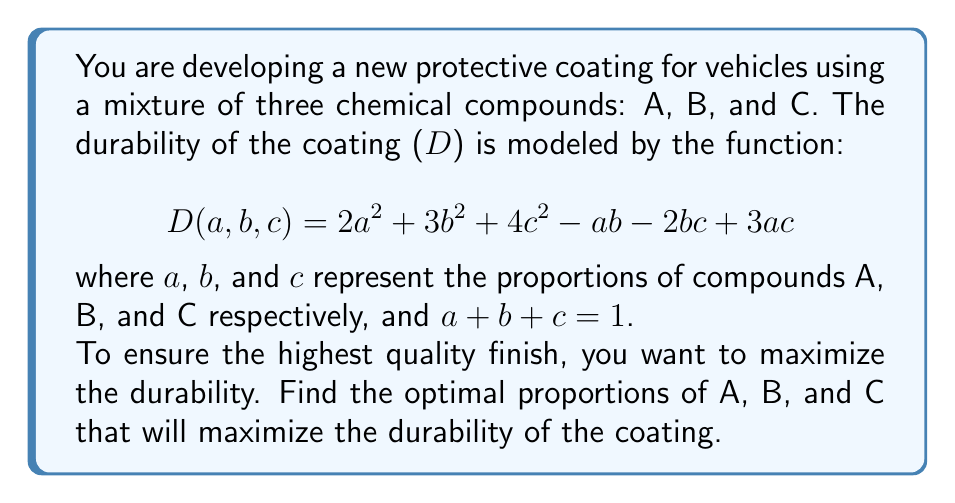Show me your answer to this math problem. To find the maximum durability, we need to optimize the function D(a,b,c) subject to the constraint a + b + c = 1. We can use the method of Lagrange multipliers:

1) Define the Lagrangian function:
   $$ L(a,b,c,λ) = 2a^2 + 3b^2 + 4c^2 - ab - 2bc + 3ac + λ(a + b + c - 1) $$

2) Calculate partial derivatives and set them to zero:
   $$ \frac{\partial L}{\partial a} = 4a - b + 3c + λ = 0 $$
   $$ \frac{\partial L}{\partial b} = 6b - a - 2c + λ = 0 $$
   $$ \frac{\partial L}{\partial c} = 8c - 2b + 3a + λ = 0 $$
   $$ \frac{\partial L}{\partial λ} = a + b + c - 1 = 0 $$

3) Solve the system of equations:
   Subtracting the first equation from the second:
   $$ 2b - 5a - 5c = 0 $$
   Subtracting the first equation from the third:
   $$ 4c - 3b = 0 $$

   From these, we can express b and c in terms of a:
   $$ c = \frac{3b}{4} $$
   $$ b = \frac{25a}{14} $$

4) Substitute these into the constraint equation:
   $$ a + \frac{25a}{14} + \frac{3}{4} \cdot \frac{25a}{14} = 1 $$

5) Solve for a:
   $$ a(1 + \frac{25}{14} + \frac{75}{56}) = 1 $$
   $$ a(\frac{56}{56} + \frac{100}{56} + \frac{75}{56}) = 1 $$
   $$ a \cdot \frac{231}{56} = 1 $$
   $$ a = \frac{56}{231} $$

6) Calculate b and c:
   $$ b = \frac{25}{14} \cdot \frac{56}{231} = \frac{100}{231} $$
   $$ c = 1 - a - b = 1 - \frac{56}{231} - \frac{100}{231} = \frac{75}{231} $$

Therefore, the optimal proportions are:
A: $\frac{56}{231}$, B: $\frac{100}{231}$, C: $\frac{75}{231}$
Answer: A: $\frac{56}{231}$, B: $\frac{100}{231}$, C: $\frac{75}{231}$ 